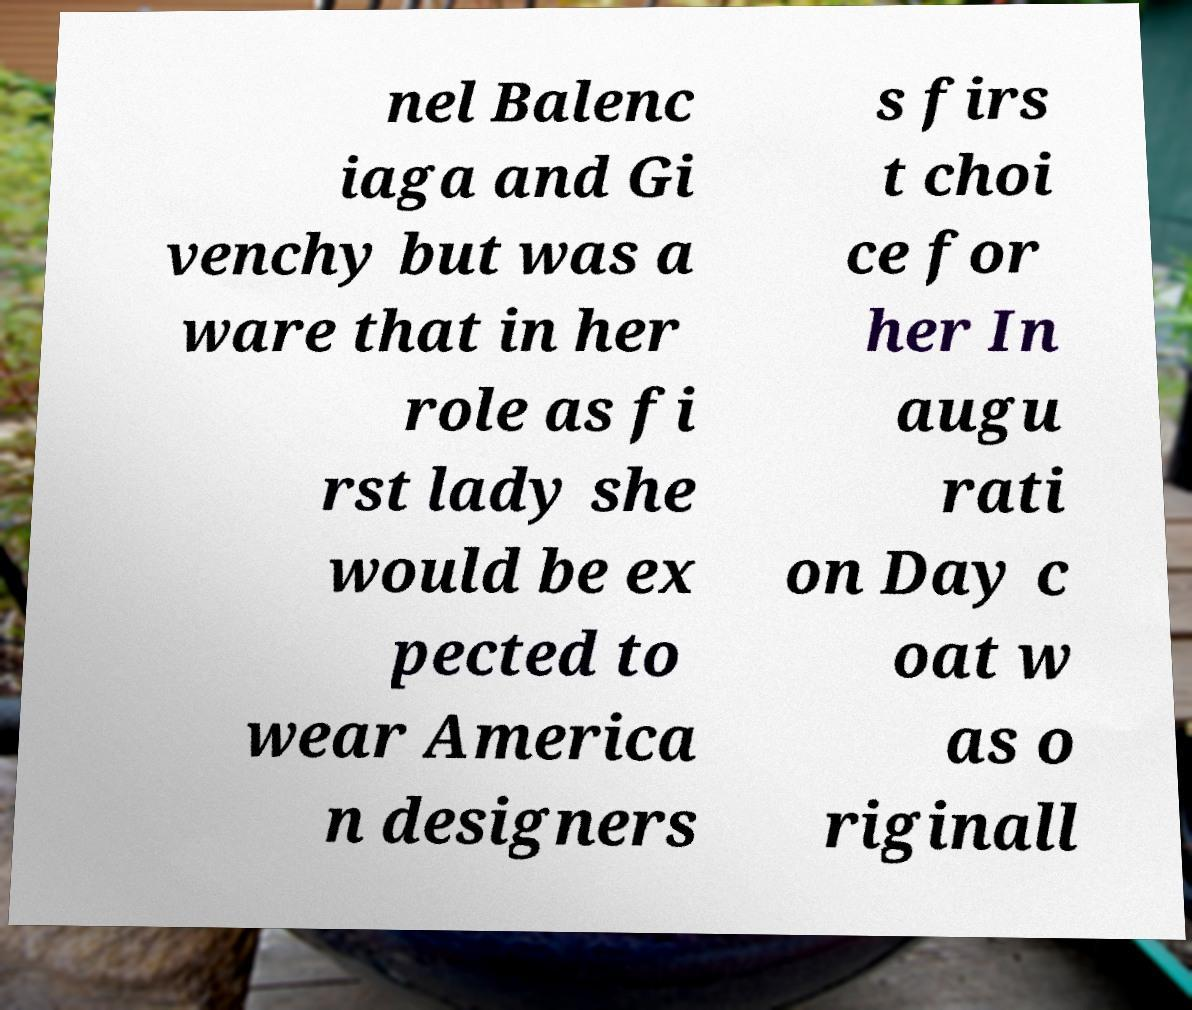Please identify and transcribe the text found in this image. nel Balenc iaga and Gi venchy but was a ware that in her role as fi rst lady she would be ex pected to wear America n designers s firs t choi ce for her In augu rati on Day c oat w as o riginall 